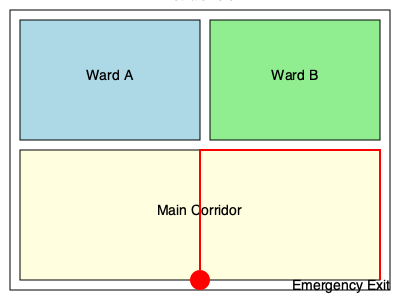Based on the hospital floor plan shown, what is the most efficient route to the emergency exit from your current position? To determine the most efficient route to the emergency exit, we need to analyze the floor plan and our current position:

1. Current position: We are located at the red circle marked "You are here" at the bottom of the main corridor.

2. Emergency exit location: The emergency exit is located at the top right corner of the floor plan.

3. Available routes:
   a. Direct path through the main corridor
   b. Path through Ward A or Ward B

4. Analyzing the routes:
   a. The direct path through the main corridor is the shortest and most straightforward route.
   b. Going through Ward A or Ward B would require navigating through patient areas and potentially encountering obstacles.

5. Hospital safety protocols:
   In emergency situations, it's crucial to use designated evacuation routes, which are typically main corridors and avoid patient care areas unless absolutely necessary.

6. Efficient route:
   The most efficient route is to follow the red line shown on the floor plan, which goes straight up the main corridor and then turns right to reach the emergency exit.

This route ensures:
- Minimal distance traveled
- Clear path without obstacles
- Adherence to standard emergency evacuation procedures
- Avoidance of patient care areas, reducing potential complications during evacuation
Answer: Straight up the main corridor, then right to the exit 